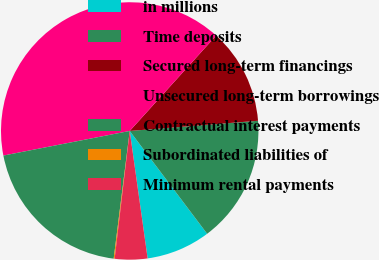Convert chart to OTSL. <chart><loc_0><loc_0><loc_500><loc_500><pie_chart><fcel>in millions<fcel>Time deposits<fcel>Secured long-term financings<fcel>Unsecured long-term borrowings<fcel>Contractual interest payments<fcel>Subordinated liabilities of<fcel>Minimum rental payments<nl><fcel>8.05%<fcel>15.99%<fcel>12.02%<fcel>39.78%<fcel>19.95%<fcel>0.12%<fcel>4.09%<nl></chart> 